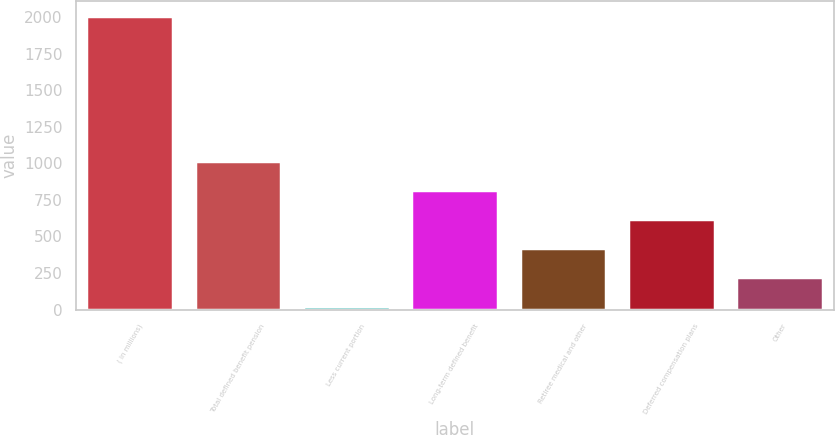Convert chart. <chart><loc_0><loc_0><loc_500><loc_500><bar_chart><fcel>( in millions)<fcel>Total defined benefit pension<fcel>Less current portion<fcel>Long-term defined benefit<fcel>Retiree medical and other<fcel>Deferred compensation plans<fcel>Other<nl><fcel>2009<fcel>1017.4<fcel>25.8<fcel>819.08<fcel>422.44<fcel>620.76<fcel>224.12<nl></chart> 